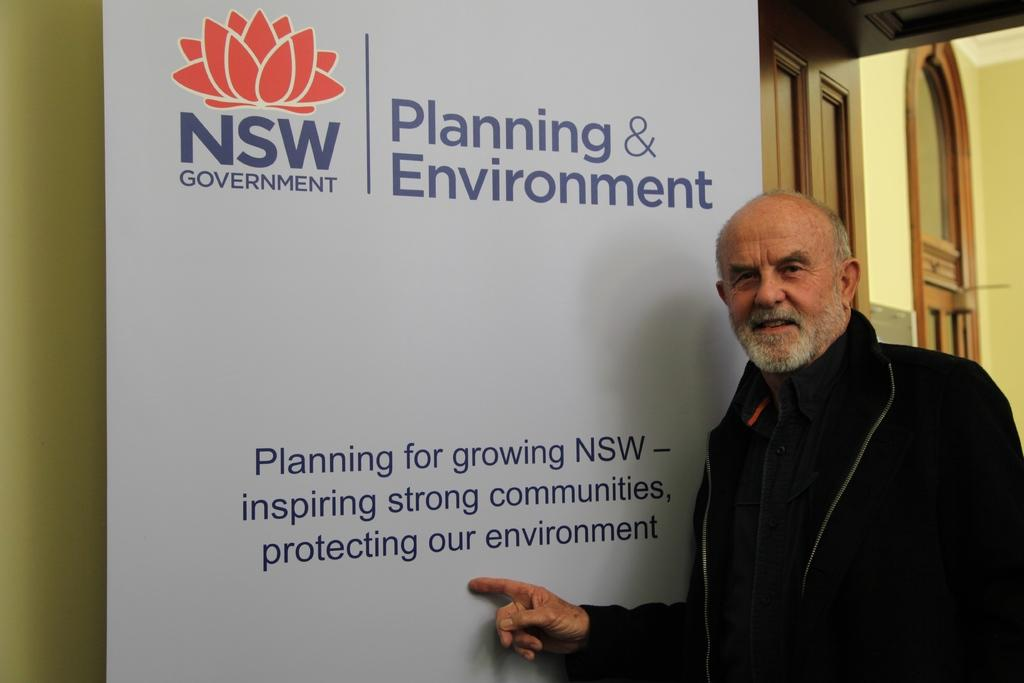What color is the jacket worn by the person in the image? The person is wearing a black jacket. What is the person pointing towards in the image? The person is pointing towards a white hoarding. What type of metal waste can be seen in the image? There is no metal waste present in the image. How many friends are visible in the image? There are no friends visible in the image, as it only features one person. 